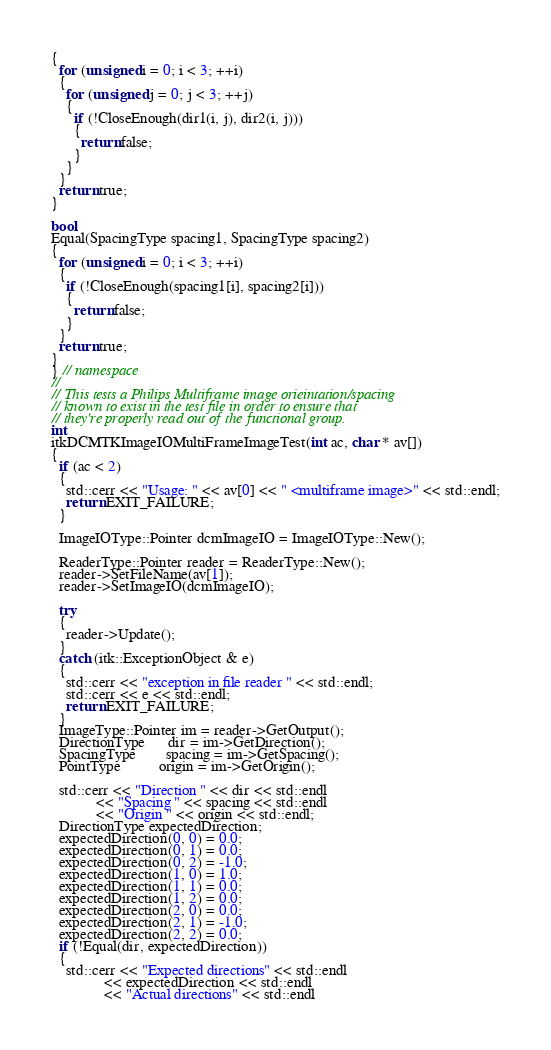<code> <loc_0><loc_0><loc_500><loc_500><_C++_>{
  for (unsigned i = 0; i < 3; ++i)
  {
    for (unsigned j = 0; j < 3; ++j)
    {
      if (!CloseEnough(dir1(i, j), dir2(i, j)))
      {
        return false;
      }
    }
  }
  return true;
}

bool
Equal(SpacingType spacing1, SpacingType spacing2)
{
  for (unsigned i = 0; i < 3; ++i)
  {
    if (!CloseEnough(spacing1[i], spacing2[i]))
    {
      return false;
    }
  }
  return true;
}
} // namespace
//
// This tests a Philips Multiframe image orieintation/spacing
// known to exist in the test file in order to ensure that
// they're properly read out of the functional group.
int
itkDCMTKImageIOMultiFrameImageTest(int ac, char * av[])
{
  if (ac < 2)
  {
    std::cerr << "Usage: " << av[0] << " <multiframe image>" << std::endl;
    return EXIT_FAILURE;
  }

  ImageIOType::Pointer dcmImageIO = ImageIOType::New();

  ReaderType::Pointer reader = ReaderType::New();
  reader->SetFileName(av[1]);
  reader->SetImageIO(dcmImageIO);

  try
  {
    reader->Update();
  }
  catch (itk::ExceptionObject & e)
  {
    std::cerr << "exception in file reader " << std::endl;
    std::cerr << e << std::endl;
    return EXIT_FAILURE;
  }
  ImageType::Pointer im = reader->GetOutput();
  DirectionType      dir = im->GetDirection();
  SpacingType        spacing = im->GetSpacing();
  PointType          origin = im->GetOrigin();

  std::cerr << "Direction " << dir << std::endl
            << "Spacing " << spacing << std::endl
            << "Origin " << origin << std::endl;
  DirectionType expectedDirection;
  expectedDirection(0, 0) = 0.0;
  expectedDirection(0, 1) = 0.0;
  expectedDirection(0, 2) = -1.0;
  expectedDirection(1, 0) = 1.0;
  expectedDirection(1, 1) = 0.0;
  expectedDirection(1, 2) = 0.0;
  expectedDirection(2, 0) = 0.0;
  expectedDirection(2, 1) = -1.0;
  expectedDirection(2, 2) = 0.0;
  if (!Equal(dir, expectedDirection))
  {
    std::cerr << "Expected directions" << std::endl
              << expectedDirection << std::endl
              << "Actual directions" << std::endl</code> 